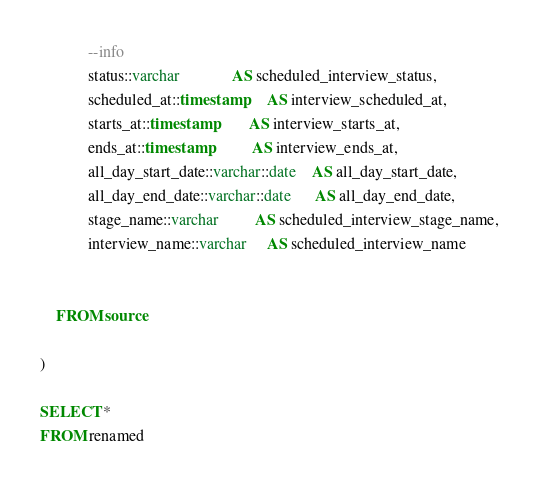<code> <loc_0><loc_0><loc_500><loc_500><_SQL_>
            --info
            status::varchar             AS scheduled_interview_status,
            scheduled_at::timestamp     AS interview_scheduled_at,
            starts_at::timestamp        AS interview_starts_at,
            ends_at::timestamp          AS interview_ends_at,
            all_day_start_date::varchar::date    AS all_day_start_date,
            all_day_end_date::varchar::date      AS all_day_end_date,
            stage_name::varchar         AS scheduled_interview_stage_name,
            interview_name::varchar     AS scheduled_interview_name


	FROM source

)

SELECT *
FROM renamed
</code> 